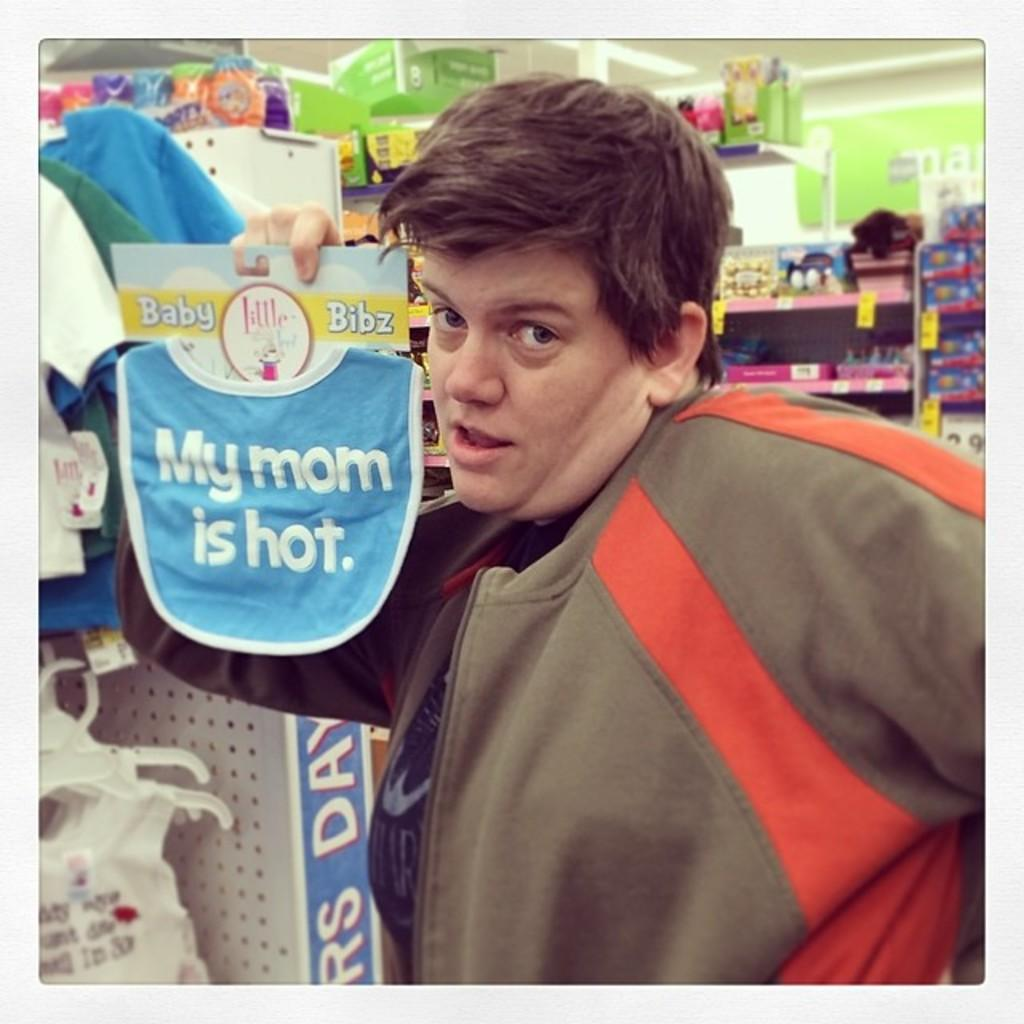Provide a one-sentence caption for the provided image. A man wearing a brown shirt is holding up a bib that says "my mom is hot". 